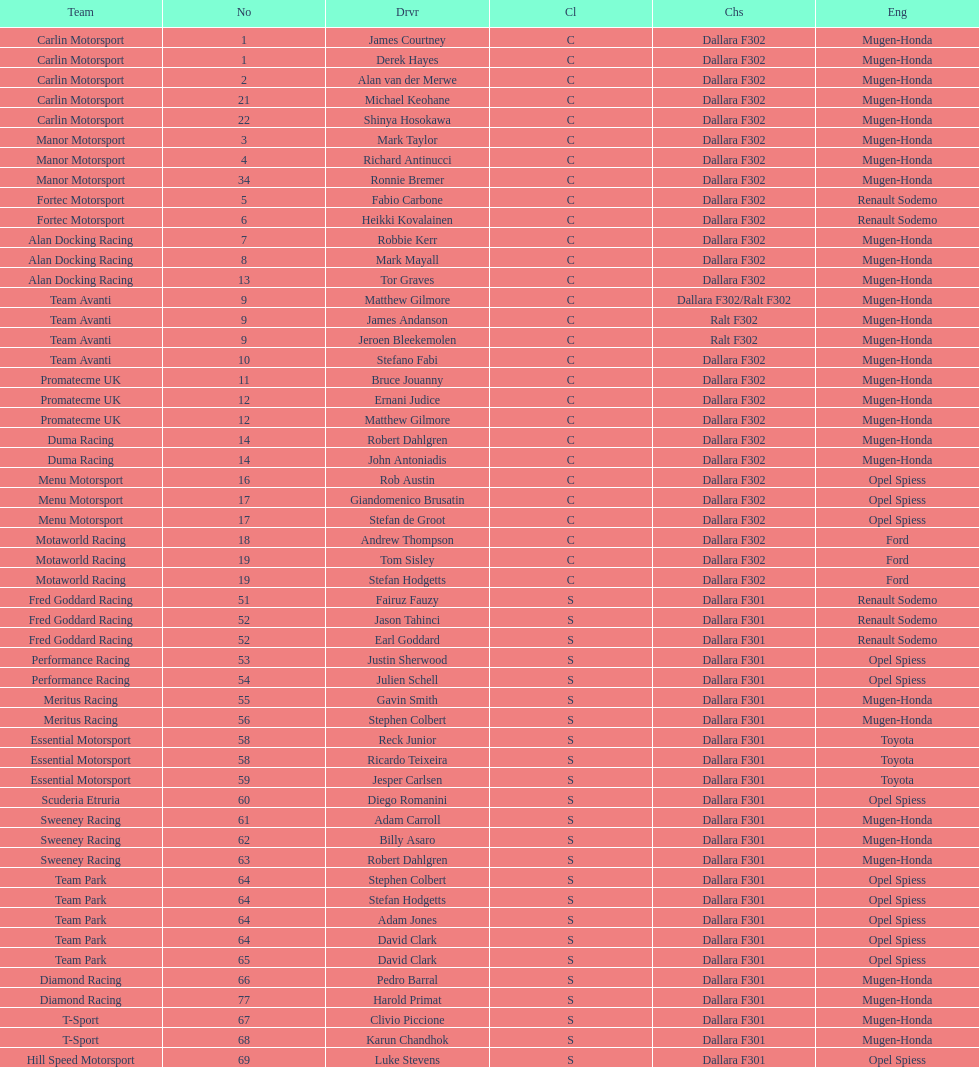I'm looking to parse the entire table for insights. Could you assist me with that? {'header': ['Team', 'No', 'Drvr', 'Cl', 'Chs', 'Eng'], 'rows': [['Carlin Motorsport', '1', 'James Courtney', 'C', 'Dallara F302', 'Mugen-Honda'], ['Carlin Motorsport', '1', 'Derek Hayes', 'C', 'Dallara F302', 'Mugen-Honda'], ['Carlin Motorsport', '2', 'Alan van der Merwe', 'C', 'Dallara F302', 'Mugen-Honda'], ['Carlin Motorsport', '21', 'Michael Keohane', 'C', 'Dallara F302', 'Mugen-Honda'], ['Carlin Motorsport', '22', 'Shinya Hosokawa', 'C', 'Dallara F302', 'Mugen-Honda'], ['Manor Motorsport', '3', 'Mark Taylor', 'C', 'Dallara F302', 'Mugen-Honda'], ['Manor Motorsport', '4', 'Richard Antinucci', 'C', 'Dallara F302', 'Mugen-Honda'], ['Manor Motorsport', '34', 'Ronnie Bremer', 'C', 'Dallara F302', 'Mugen-Honda'], ['Fortec Motorsport', '5', 'Fabio Carbone', 'C', 'Dallara F302', 'Renault Sodemo'], ['Fortec Motorsport', '6', 'Heikki Kovalainen', 'C', 'Dallara F302', 'Renault Sodemo'], ['Alan Docking Racing', '7', 'Robbie Kerr', 'C', 'Dallara F302', 'Mugen-Honda'], ['Alan Docking Racing', '8', 'Mark Mayall', 'C', 'Dallara F302', 'Mugen-Honda'], ['Alan Docking Racing', '13', 'Tor Graves', 'C', 'Dallara F302', 'Mugen-Honda'], ['Team Avanti', '9', 'Matthew Gilmore', 'C', 'Dallara F302/Ralt F302', 'Mugen-Honda'], ['Team Avanti', '9', 'James Andanson', 'C', 'Ralt F302', 'Mugen-Honda'], ['Team Avanti', '9', 'Jeroen Bleekemolen', 'C', 'Ralt F302', 'Mugen-Honda'], ['Team Avanti', '10', 'Stefano Fabi', 'C', 'Dallara F302', 'Mugen-Honda'], ['Promatecme UK', '11', 'Bruce Jouanny', 'C', 'Dallara F302', 'Mugen-Honda'], ['Promatecme UK', '12', 'Ernani Judice', 'C', 'Dallara F302', 'Mugen-Honda'], ['Promatecme UK', '12', 'Matthew Gilmore', 'C', 'Dallara F302', 'Mugen-Honda'], ['Duma Racing', '14', 'Robert Dahlgren', 'C', 'Dallara F302', 'Mugen-Honda'], ['Duma Racing', '14', 'John Antoniadis', 'C', 'Dallara F302', 'Mugen-Honda'], ['Menu Motorsport', '16', 'Rob Austin', 'C', 'Dallara F302', 'Opel Spiess'], ['Menu Motorsport', '17', 'Giandomenico Brusatin', 'C', 'Dallara F302', 'Opel Spiess'], ['Menu Motorsport', '17', 'Stefan de Groot', 'C', 'Dallara F302', 'Opel Spiess'], ['Motaworld Racing', '18', 'Andrew Thompson', 'C', 'Dallara F302', 'Ford'], ['Motaworld Racing', '19', 'Tom Sisley', 'C', 'Dallara F302', 'Ford'], ['Motaworld Racing', '19', 'Stefan Hodgetts', 'C', 'Dallara F302', 'Ford'], ['Fred Goddard Racing', '51', 'Fairuz Fauzy', 'S', 'Dallara F301', 'Renault Sodemo'], ['Fred Goddard Racing', '52', 'Jason Tahinci', 'S', 'Dallara F301', 'Renault Sodemo'], ['Fred Goddard Racing', '52', 'Earl Goddard', 'S', 'Dallara F301', 'Renault Sodemo'], ['Performance Racing', '53', 'Justin Sherwood', 'S', 'Dallara F301', 'Opel Spiess'], ['Performance Racing', '54', 'Julien Schell', 'S', 'Dallara F301', 'Opel Spiess'], ['Meritus Racing', '55', 'Gavin Smith', 'S', 'Dallara F301', 'Mugen-Honda'], ['Meritus Racing', '56', 'Stephen Colbert', 'S', 'Dallara F301', 'Mugen-Honda'], ['Essential Motorsport', '58', 'Reck Junior', 'S', 'Dallara F301', 'Toyota'], ['Essential Motorsport', '58', 'Ricardo Teixeira', 'S', 'Dallara F301', 'Toyota'], ['Essential Motorsport', '59', 'Jesper Carlsen', 'S', 'Dallara F301', 'Toyota'], ['Scuderia Etruria', '60', 'Diego Romanini', 'S', 'Dallara F301', 'Opel Spiess'], ['Sweeney Racing', '61', 'Adam Carroll', 'S', 'Dallara F301', 'Mugen-Honda'], ['Sweeney Racing', '62', 'Billy Asaro', 'S', 'Dallara F301', 'Mugen-Honda'], ['Sweeney Racing', '63', 'Robert Dahlgren', 'S', 'Dallara F301', 'Mugen-Honda'], ['Team Park', '64', 'Stephen Colbert', 'S', 'Dallara F301', 'Opel Spiess'], ['Team Park', '64', 'Stefan Hodgetts', 'S', 'Dallara F301', 'Opel Spiess'], ['Team Park', '64', 'Adam Jones', 'S', 'Dallara F301', 'Opel Spiess'], ['Team Park', '64', 'David Clark', 'S', 'Dallara F301', 'Opel Spiess'], ['Team Park', '65', 'David Clark', 'S', 'Dallara F301', 'Opel Spiess'], ['Diamond Racing', '66', 'Pedro Barral', 'S', 'Dallara F301', 'Mugen-Honda'], ['Diamond Racing', '77', 'Harold Primat', 'S', 'Dallara F301', 'Mugen-Honda'], ['T-Sport', '67', 'Clivio Piccione', 'S', 'Dallara F301', 'Mugen-Honda'], ['T-Sport', '68', 'Karun Chandhok', 'S', 'Dallara F301', 'Mugen-Honda'], ['Hill Speed Motorsport', '69', 'Luke Stevens', 'S', 'Dallara F301', 'Opel Spiess']]} Which engine was used the most by teams this season? Mugen-Honda. 